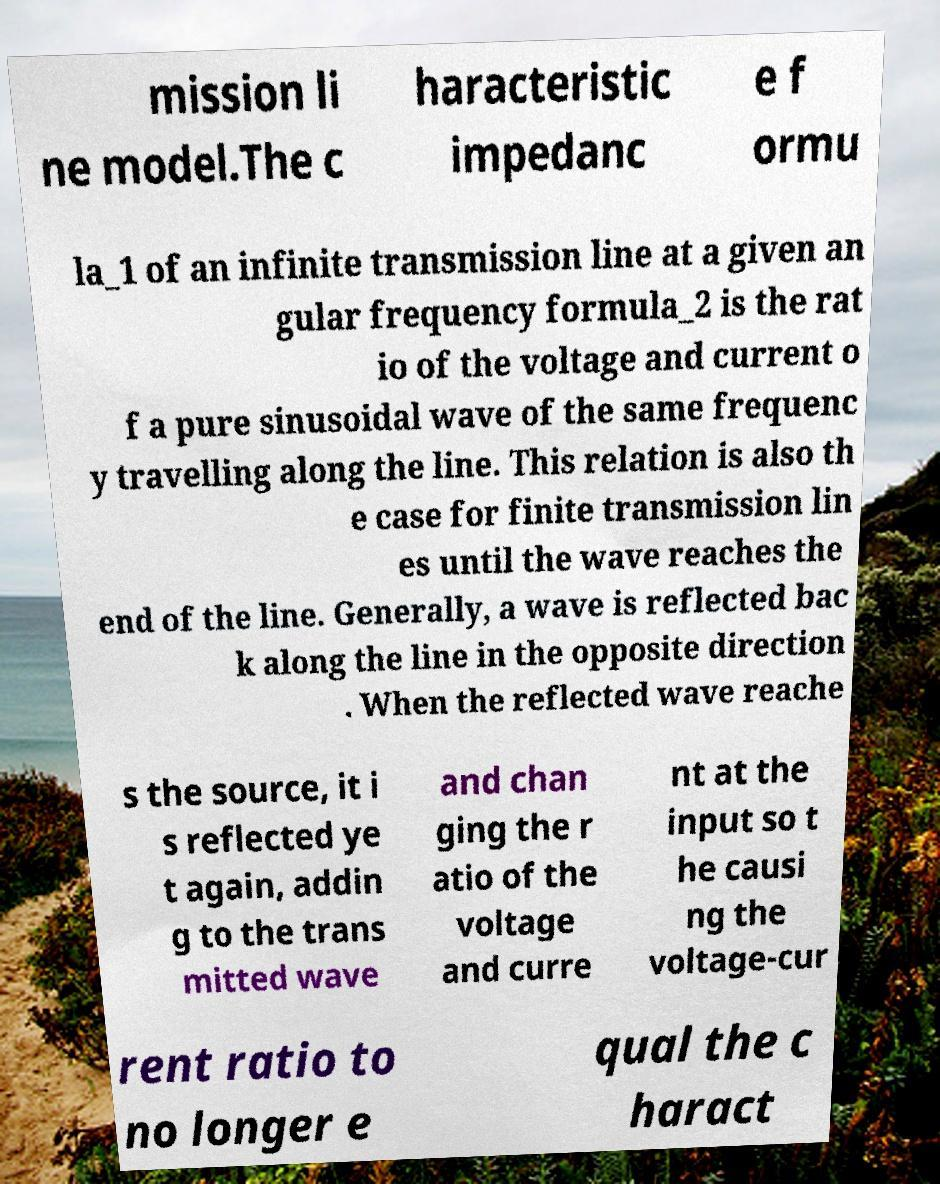Please identify and transcribe the text found in this image. mission li ne model.The c haracteristic impedanc e f ormu la_1 of an infinite transmission line at a given an gular frequency formula_2 is the rat io of the voltage and current o f a pure sinusoidal wave of the same frequenc y travelling along the line. This relation is also th e case for finite transmission lin es until the wave reaches the end of the line. Generally, a wave is reflected bac k along the line in the opposite direction . When the reflected wave reache s the source, it i s reflected ye t again, addin g to the trans mitted wave and chan ging the r atio of the voltage and curre nt at the input so t he causi ng the voltage-cur rent ratio to no longer e qual the c haract 